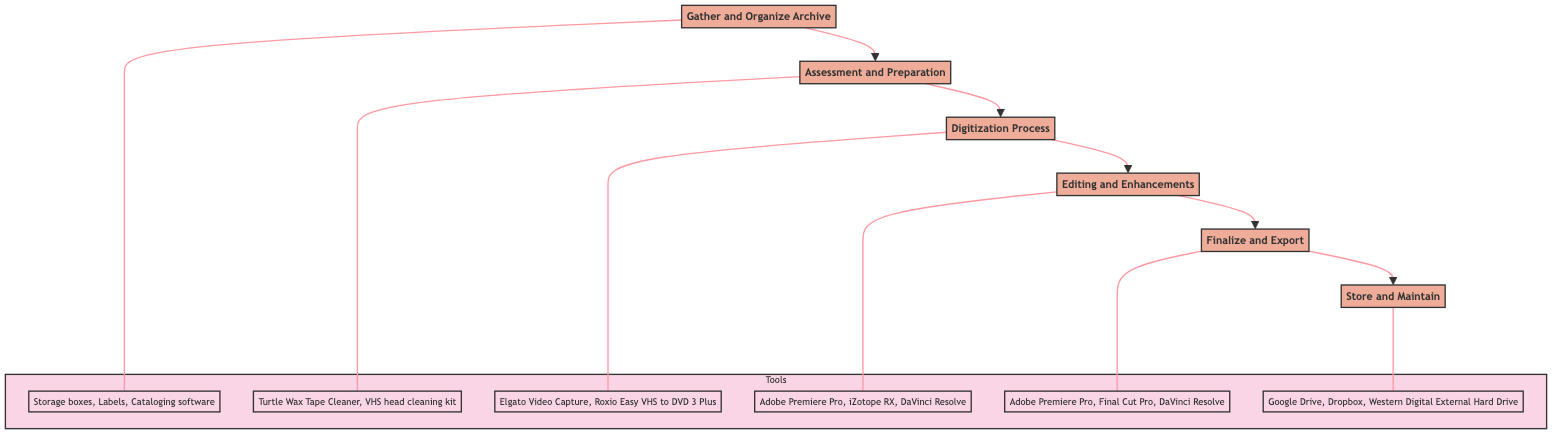What's the first step in this process? The first step is "Gather and Organize Archive," as it is at the bottom of the flowchart.
Answer: Gather and Organize Archive How many total steps are there in the diagram? There are six steps in total, specifically listed from "Gather and Organize Archive" to "Store and Maintain."
Answer: 6 What is the last step before finalizing and exporting? The last step before "Finalize and Export" is "Editing and Enhancements," as it directly precedes it in the flow.
Answer: Editing and Enhancements Which tools are used in the digitization process? The tools associated with the "Digitization Process" are listed underneath and include "Elgato Video Capture," "Roxio Easy VHS to DVD 3 Plus," and "Blackmagic Intensity Pro."
Answer: Elgato Video Capture, Roxio Easy VHS to DVD 3 Plus, Blackmagic Intensity Pro What step follows assessment and preparation? The step that follows "Assessment and Preparation" is "Digitization Process," as the flow moves upward from the assessment.
Answer: Digitization Process Which step is directly connected to storing and maintaining? The step directly connected to "Store and Maintain" is "Finalize and Export," as it flows right before storing and maintaining.
Answer: Finalize and Export What is the purpose of the tools section in the diagram? The purpose of the tools section is to state the specific tools used at each main step of the process, aiding those following the flowchart to know what to utilize at each phase.
Answer: Specific tools used at each main step Which step involves evaluating the condition of the footage? The step that involves evaluating the condition of the footage is "Assessment and Preparation."
Answer: Assessment and Preparation How many tools are listed under the editing and enhancements step? There are three tools listed under "Editing and Enhancements," which include "Adobe Premiere Pro," "iZotope RX," and "DaVinci Resolve."
Answer: 3 